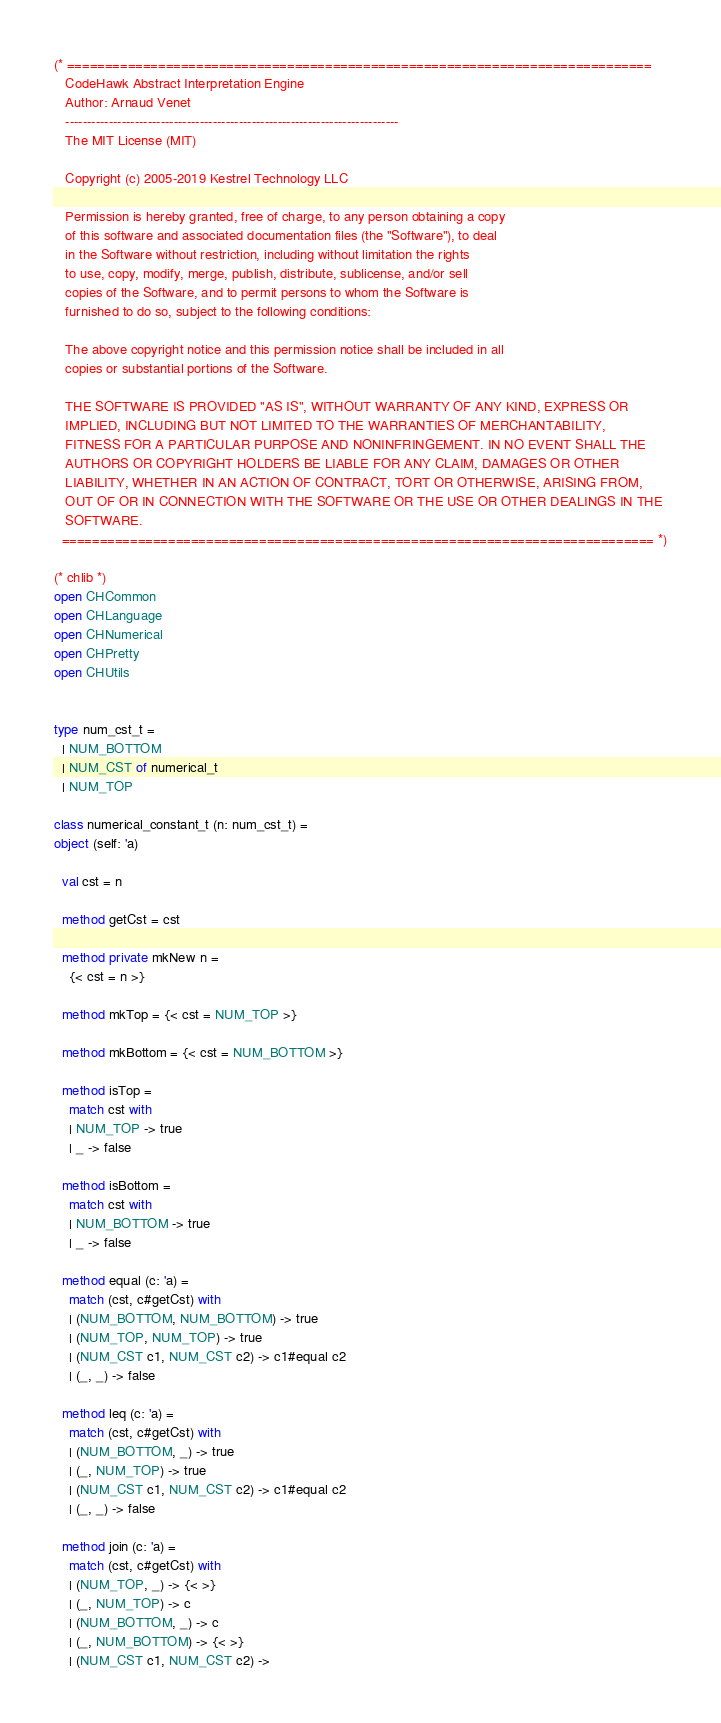<code> <loc_0><loc_0><loc_500><loc_500><_OCaml_>(* =============================================================================
   CodeHawk Abstract Interpretation Engine
   Author: Arnaud Venet
   -----------------------------------------------------------------------------
   The MIT License (MIT)
 
   Copyright (c) 2005-2019 Kestrel Technology LLC

   Permission is hereby granted, free of charge, to any person obtaining a copy
   of this software and associated documentation files (the "Software"), to deal
   in the Software without restriction, including without limitation the rights
   to use, copy, modify, merge, publish, distribute, sublicense, and/or sell
   copies of the Software, and to permit persons to whom the Software is
   furnished to do so, subject to the following conditions:
 
   The above copyright notice and this permission notice shall be included in all
   copies or substantial portions of the Software.
  
   THE SOFTWARE IS PROVIDED "AS IS", WITHOUT WARRANTY OF ANY KIND, EXPRESS OR
   IMPLIED, INCLUDING BUT NOT LIMITED TO THE WARRANTIES OF MERCHANTABILITY,
   FITNESS FOR A PARTICULAR PURPOSE AND NONINFRINGEMENT. IN NO EVENT SHALL THE
   AUTHORS OR COPYRIGHT HOLDERS BE LIABLE FOR ANY CLAIM, DAMAGES OR OTHER
   LIABILITY, WHETHER IN AN ACTION OF CONTRACT, TORT OR OTHERWISE, ARISING FROM,
   OUT OF OR IN CONNECTION WITH THE SOFTWARE OR THE USE OR OTHER DEALINGS IN THE
   SOFTWARE.
  ============================================================================== *)

(* chlib *)
open CHCommon
open CHLanguage   
open CHNumerical   
open CHPretty
open CHUtils


type num_cst_t =
  | NUM_BOTTOM
  | NUM_CST of numerical_t
  | NUM_TOP
  
class numerical_constant_t (n: num_cst_t) =
object (self: 'a)
     
  val cst = n
          
  method getCst = cst
                
  method private mkNew n =
    {< cst = n >}
    
  method mkTop = {< cst = NUM_TOP >}
               
  method mkBottom = {< cst = NUM_BOTTOM >}
                  
  method isTop =
    match cst with
    | NUM_TOP -> true
    | _ -> false
         
  method isBottom =
    match cst with
    | NUM_BOTTOM -> true
    | _ -> false
         
  method equal (c: 'a) =
    match (cst, c#getCst) with
    | (NUM_BOTTOM, NUM_BOTTOM) -> true
    | (NUM_TOP, NUM_TOP) -> true
    | (NUM_CST c1, NUM_CST c2) -> c1#equal c2
    | (_, _) -> false 
              
  method leq (c: 'a) =
    match (cst, c#getCst) with
    | (NUM_BOTTOM, _) -> true
    | (_, NUM_TOP) -> true
    | (NUM_CST c1, NUM_CST c2) -> c1#equal c2
    | (_, _) -> false
              
  method join (c: 'a) =
    match (cst, c#getCst) with
    | (NUM_TOP, _) -> {< >}
    | (_, NUM_TOP) -> c
    | (NUM_BOTTOM, _) -> c
    | (_, NUM_BOTTOM) -> {< >}
    | (NUM_CST c1, NUM_CST c2) -></code> 